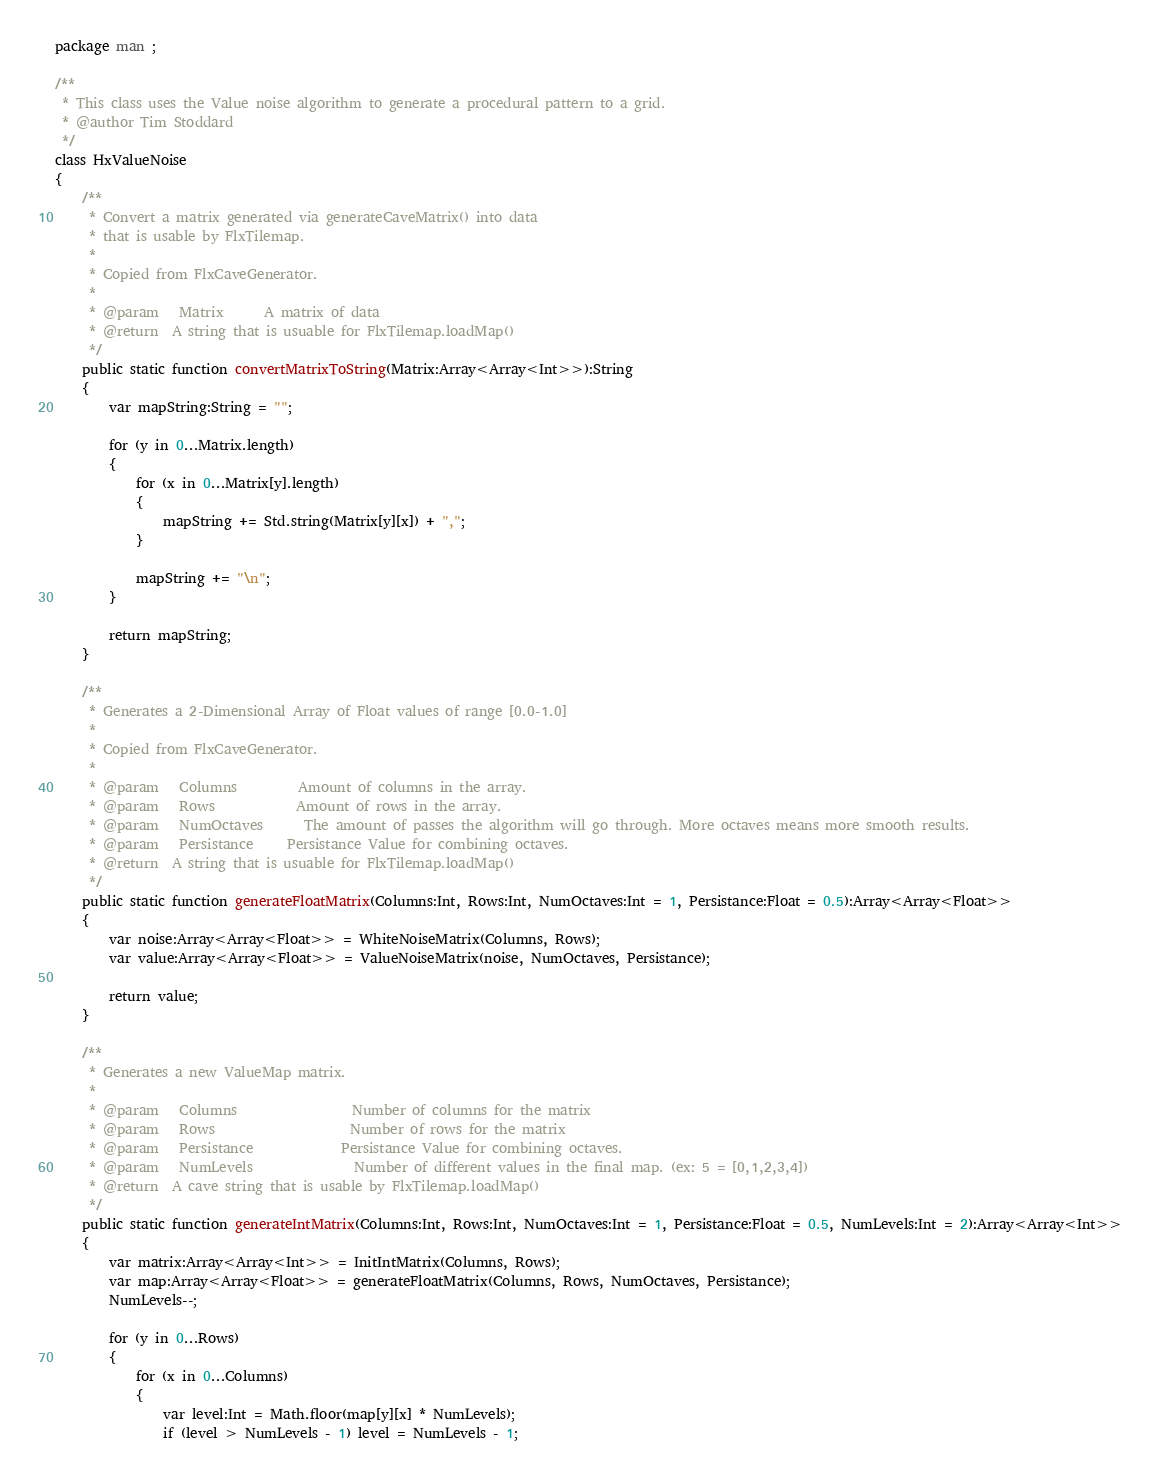<code> <loc_0><loc_0><loc_500><loc_500><_Haxe_>package man ;

/**
 * This class uses the Value noise algorithm to generate a procedural pattern to a grid.
 * @author Tim Stoddard
 */
class HxValueNoise
{
	/**
	 * Convert a matrix generated via generateCaveMatrix() into data 
	 * that is usable by FlxTilemap.
	 * 
	 * Copied from FlxCaveGenerator.
	 * 
	 * @param 	Matrix		A matrix of data
	 * @return 	A string that is usuable for FlxTilemap.loadMap()
	 */
	public static function convertMatrixToString(Matrix:Array<Array<Int>>):String
	{
		var mapString:String = "";
		
		for (y in 0...Matrix.length)
		{
			for (x in 0...Matrix[y].length)
			{
				mapString += Std.string(Matrix[y][x]) + ",";
			}
			
			mapString += "\n";
		}
		
		return mapString;
	}
	
	/**
	 * Generates a 2-Dimensional Array of Float values of range [0.0-1.0]
	 * 
	 * Copied from FlxCaveGenerator.
	 * 
	 * @param 	Columns			Amount of columns in the array.
	 * @param	Rows			Amount of rows in the array.
	 * @param	NumOctaves		The amount of passes the algorithm will go through. More octaves means more smooth results.
	 * @param	Persistance		Persistance Value for combining octaves.
	 * @return 	A string that is usuable for FlxTilemap.loadMap()
	 */
	public static function generateFloatMatrix(Columns:Int, Rows:Int, NumOctaves:Int = 1, Persistance:Float = 0.5):Array<Array<Float>>
	{
		var noise:Array<Array<Float>> = WhiteNoiseMatrix(Columns, Rows);
		var value:Array<Array<Float>> = ValueNoiseMatrix(noise, NumOctaves, Persistance);
		
		return value;
	}
	
	/**
	 * Generates a new ValueMap matrix.
	 * 
	 * @param	Columns 				Number of columns for the matrix
	 * @param	Rows					Number of rows for the matrix
	 * @param	Persistance				Persistance Value for combining octaves.
	 * @param	NumLevels			 	Number of different values in the final map. (ex: 5 = [0,1,2,3,4])
	 * @return	A cave string that is usable by FlxTilemap.loadMap()
	 */
	public static function generateIntMatrix(Columns:Int, Rows:Int, NumOctaves:Int = 1, Persistance:Float = 0.5, NumLevels:Int = 2):Array<Array<Int>>
	{
		var matrix:Array<Array<Int>> = InitIntMatrix(Columns, Rows);
		var map:Array<Array<Float>> = generateFloatMatrix(Columns, Rows, NumOctaves, Persistance);
		NumLevels--;
		
		for (y in 0...Rows)
		{
			for (x in 0...Columns)
			{
				var level:Int = Math.floor(map[y][x] * NumLevels);
				if (level > NumLevels - 1) level = NumLevels - 1;</code> 